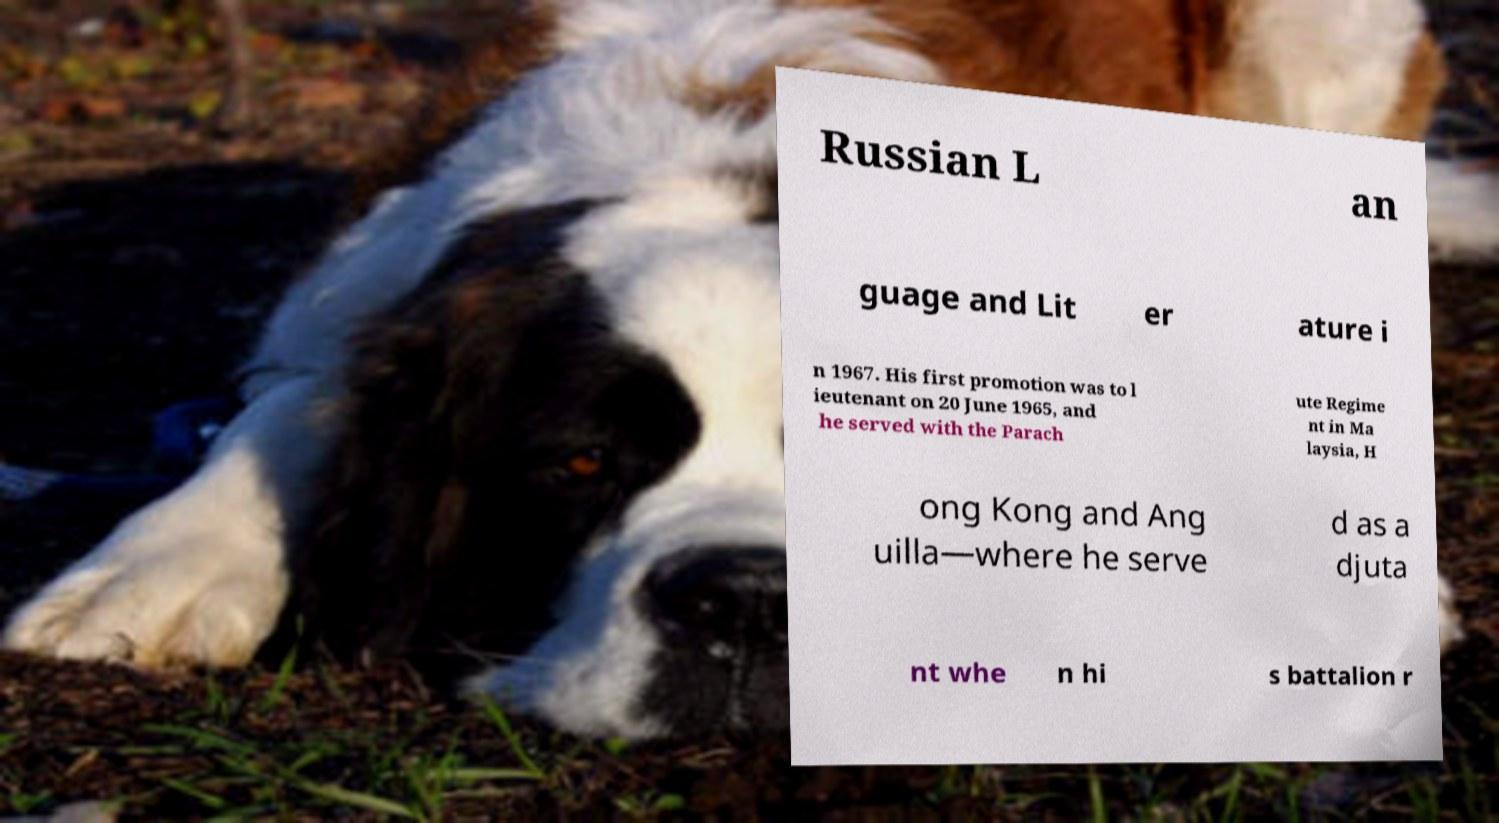Please identify and transcribe the text found in this image. Russian L an guage and Lit er ature i n 1967. His first promotion was to l ieutenant on 20 June 1965, and he served with the Parach ute Regime nt in Ma laysia, H ong Kong and Ang uilla—where he serve d as a djuta nt whe n hi s battalion r 